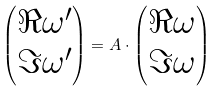Convert formula to latex. <formula><loc_0><loc_0><loc_500><loc_500>\begin{pmatrix} \Re \omega ^ { \prime } \\ \Im \omega ^ { \prime } \end{pmatrix} = A \cdot \begin{pmatrix} \Re \omega \\ \Im \omega \end{pmatrix}</formula> 